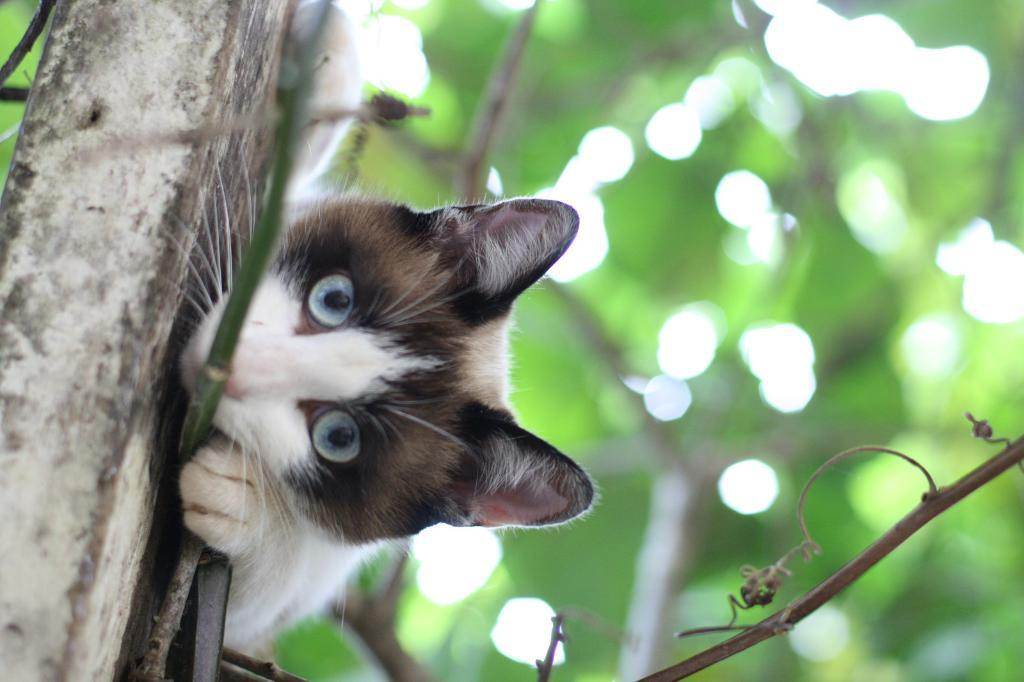What type of animal is in the image? There is a cat in the image. Can you describe the cat's location in relation to another object? The cat is beside a wooden object. What color is the background of the image? The background of the image is green. What type of plantation can be seen in the image? There is no plantation present in the image. What mode of transportation is visible in the image? There is no mode of transportation visible in the image. 